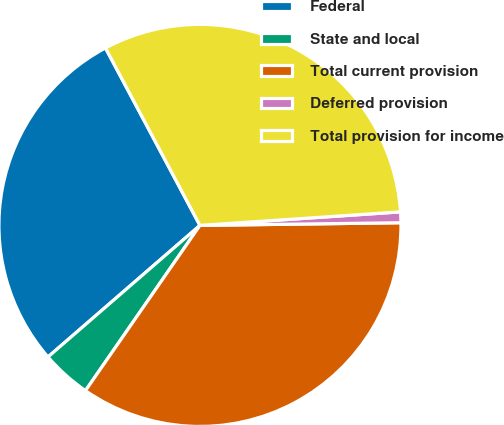<chart> <loc_0><loc_0><loc_500><loc_500><pie_chart><fcel>Federal<fcel>State and local<fcel>Total current provision<fcel>Deferred provision<fcel>Total provision for income<nl><fcel>28.57%<fcel>4.0%<fcel>34.85%<fcel>0.86%<fcel>31.71%<nl></chart> 